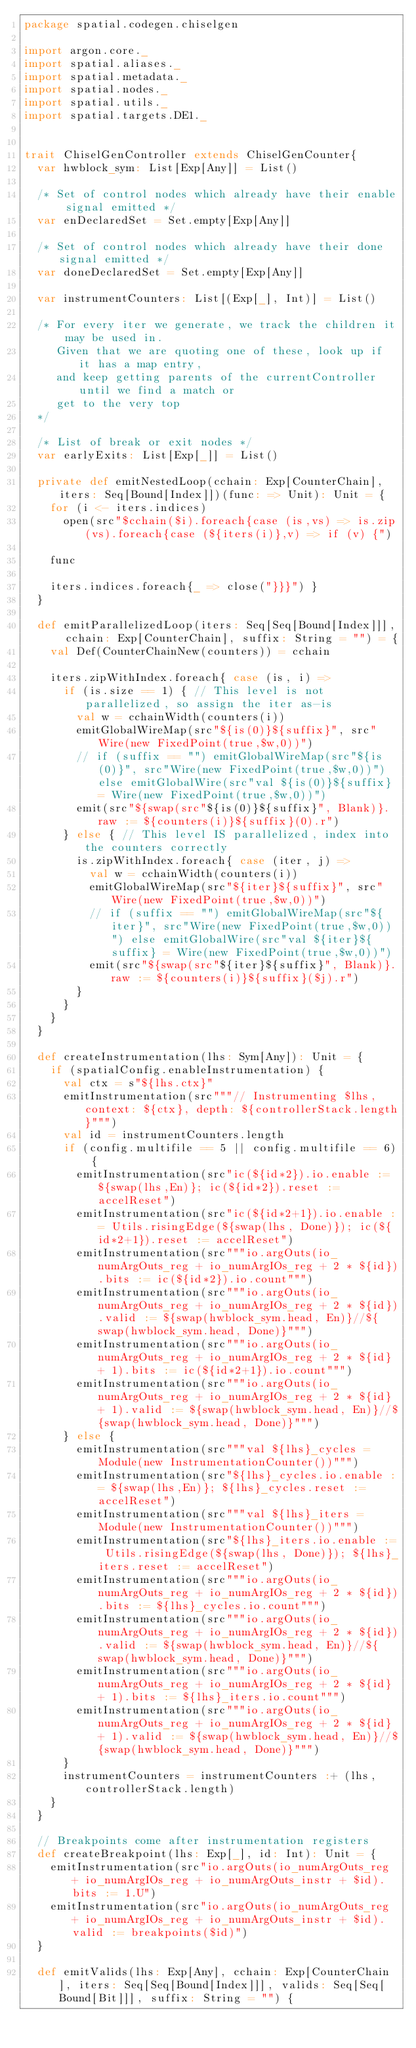<code> <loc_0><loc_0><loc_500><loc_500><_Scala_>package spatial.codegen.chiselgen

import argon.core._
import spatial.aliases._
import spatial.metadata._
import spatial.nodes._
import spatial.utils._
import spatial.targets.DE1._


trait ChiselGenController extends ChiselGenCounter{
  var hwblock_sym: List[Exp[Any]] = List()

  /* Set of control nodes which already have their enable signal emitted */
  var enDeclaredSet = Set.empty[Exp[Any]]

  /* Set of control nodes which already have their done signal emitted */
  var doneDeclaredSet = Set.empty[Exp[Any]]

  var instrumentCounters: List[(Exp[_], Int)] = List()

  /* For every iter we generate, we track the children it may be used in.
     Given that we are quoting one of these, look up if it has a map entry,
     and keep getting parents of the currentController until we find a match or 
     get to the very top
  */

  /* List of break or exit nodes */
  var earlyExits: List[Exp[_]] = List()

  private def emitNestedLoop(cchain: Exp[CounterChain], iters: Seq[Bound[Index]])(func: => Unit): Unit = {
    for (i <- iters.indices)
      open(src"$cchain($i).foreach{case (is,vs) => is.zip(vs).foreach{case (${iters(i)},v) => if (v) {")

    func

    iters.indices.foreach{_ => close("}}}") }
  }

  def emitParallelizedLoop(iters: Seq[Seq[Bound[Index]]], cchain: Exp[CounterChain], suffix: String = "") = {
    val Def(CounterChainNew(counters)) = cchain

    iters.zipWithIndex.foreach{ case (is, i) =>
      if (is.size == 1) { // This level is not parallelized, so assign the iter as-is
        val w = cchainWidth(counters(i))
        emitGlobalWireMap(src"${is(0)}${suffix}", src"Wire(new FixedPoint(true,$w,0))")
        // if (suffix == "") emitGlobalWireMap(src"${is(0)}", src"Wire(new FixedPoint(true,$w,0))") else emitGlobalWire(src"val ${is(0)}${suffix} = Wire(new FixedPoint(true,$w,0))")
        emit(src"${swap(src"${is(0)}${suffix}", Blank)}.raw := ${counters(i)}${suffix}(0).r")
      } else { // This level IS parallelized, index into the counters correctly
        is.zipWithIndex.foreach{ case (iter, j) =>
          val w = cchainWidth(counters(i))
          emitGlobalWireMap(src"${iter}${suffix}", src"Wire(new FixedPoint(true,$w,0))")
          // if (suffix == "") emitGlobalWireMap(src"${iter}", src"Wire(new FixedPoint(true,$w,0))") else emitGlobalWire(src"val ${iter}${suffix} = Wire(new FixedPoint(true,$w,0))")
          emit(src"${swap(src"${iter}${suffix}", Blank)}.raw := ${counters(i)}${suffix}($j).r")
        }
      }
    }
  }

  def createInstrumentation(lhs: Sym[Any]): Unit = {
    if (spatialConfig.enableInstrumentation) {
      val ctx = s"${lhs.ctx}"
      emitInstrumentation(src"""// Instrumenting $lhs, context: ${ctx}, depth: ${controllerStack.length}""")
      val id = instrumentCounters.length
      if (config.multifile == 5 || config.multifile == 6) {
        emitInstrumentation(src"ic(${id*2}).io.enable := ${swap(lhs,En)}; ic(${id*2}).reset := accelReset")
        emitInstrumentation(src"ic(${id*2+1}).io.enable := Utils.risingEdge(${swap(lhs, Done)}); ic(${id*2+1}).reset := accelReset")
        emitInstrumentation(src"""io.argOuts(io_numArgOuts_reg + io_numArgIOs_reg + 2 * ${id}).bits := ic(${id*2}).io.count""")
        emitInstrumentation(src"""io.argOuts(io_numArgOuts_reg + io_numArgIOs_reg + 2 * ${id}).valid := ${swap(hwblock_sym.head, En)}//${swap(hwblock_sym.head, Done)}""")
        emitInstrumentation(src"""io.argOuts(io_numArgOuts_reg + io_numArgIOs_reg + 2 * ${id} + 1).bits := ic(${id*2+1}).io.count""")
        emitInstrumentation(src"""io.argOuts(io_numArgOuts_reg + io_numArgIOs_reg + 2 * ${id} + 1).valid := ${swap(hwblock_sym.head, En)}//${swap(hwblock_sym.head, Done)}""")        
      } else {
        emitInstrumentation(src"""val ${lhs}_cycles = Module(new InstrumentationCounter())""")
        emitInstrumentation(src"${lhs}_cycles.io.enable := ${swap(lhs,En)}; ${lhs}_cycles.reset := accelReset")
        emitInstrumentation(src"""val ${lhs}_iters = Module(new InstrumentationCounter())""")
        emitInstrumentation(src"${lhs}_iters.io.enable := Utils.risingEdge(${swap(lhs, Done)}); ${lhs}_iters.reset := accelReset")
        emitInstrumentation(src"""io.argOuts(io_numArgOuts_reg + io_numArgIOs_reg + 2 * ${id}).bits := ${lhs}_cycles.io.count""")
        emitInstrumentation(src"""io.argOuts(io_numArgOuts_reg + io_numArgIOs_reg + 2 * ${id}).valid := ${swap(hwblock_sym.head, En)}//${swap(hwblock_sym.head, Done)}""")
        emitInstrumentation(src"""io.argOuts(io_numArgOuts_reg + io_numArgIOs_reg + 2 * ${id} + 1).bits := ${lhs}_iters.io.count""")
        emitInstrumentation(src"""io.argOuts(io_numArgOuts_reg + io_numArgIOs_reg + 2 * ${id} + 1).valid := ${swap(hwblock_sym.head, En)}//${swap(hwblock_sym.head, Done)}""")        
      }
      instrumentCounters = instrumentCounters :+ (lhs, controllerStack.length)
    }
  }

  // Breakpoints come after instrumentation registers
  def createBreakpoint(lhs: Exp[_], id: Int): Unit = {
    emitInstrumentation(src"io.argOuts(io_numArgOuts_reg + io_numArgIOs_reg + io_numArgOuts_instr + $id).bits := 1.U")
    emitInstrumentation(src"io.argOuts(io_numArgOuts_reg + io_numArgIOs_reg + io_numArgOuts_instr + $id).valid := breakpoints($id)")
  }

  def emitValids(lhs: Exp[Any], cchain: Exp[CounterChain], iters: Seq[Seq[Bound[Index]]], valids: Seq[Seq[Bound[Bit]]], suffix: String = "") {</code> 